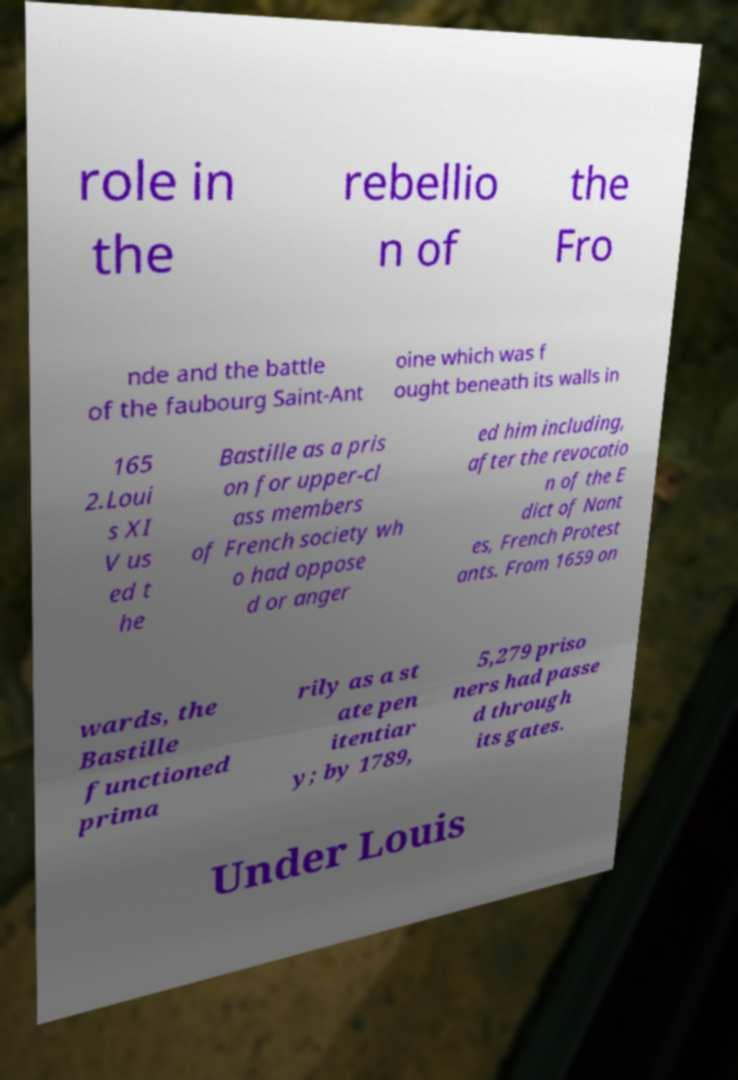Could you extract and type out the text from this image? role in the rebellio n of the Fro nde and the battle of the faubourg Saint-Ant oine which was f ought beneath its walls in 165 2.Loui s XI V us ed t he Bastille as a pris on for upper-cl ass members of French society wh o had oppose d or anger ed him including, after the revocatio n of the E dict of Nant es, French Protest ants. From 1659 on wards, the Bastille functioned prima rily as a st ate pen itentiar y; by 1789, 5,279 priso ners had passe d through its gates. Under Louis 